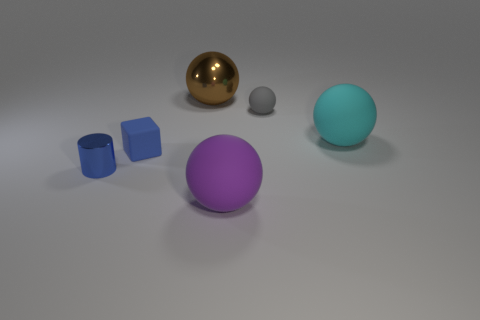There is a blue metal object that is the same size as the blue matte thing; what is its shape?
Provide a short and direct response. Cylinder. The rubber thing that is left of the large thing that is in front of the small matte thing that is on the left side of the large brown ball is what shape?
Your response must be concise. Cube. Are there the same number of small matte things behind the gray thing and tiny yellow rubber things?
Provide a succinct answer. Yes. Is the size of the cube the same as the gray matte ball?
Keep it short and to the point. Yes. How many matte things are small blue blocks or gray balls?
Keep it short and to the point. 2. What is the material of the cyan thing that is the same size as the brown metallic ball?
Offer a terse response. Rubber. What number of other things are there of the same material as the tiny sphere
Give a very brief answer. 3. Is the number of tiny things that are on the left side of the blue block less than the number of small purple metal cylinders?
Your response must be concise. No. Does the big brown object have the same shape as the small blue matte object?
Offer a terse response. No. What is the size of the metallic object in front of the small object on the right side of the large sphere that is in front of the cyan sphere?
Ensure brevity in your answer.  Small. 